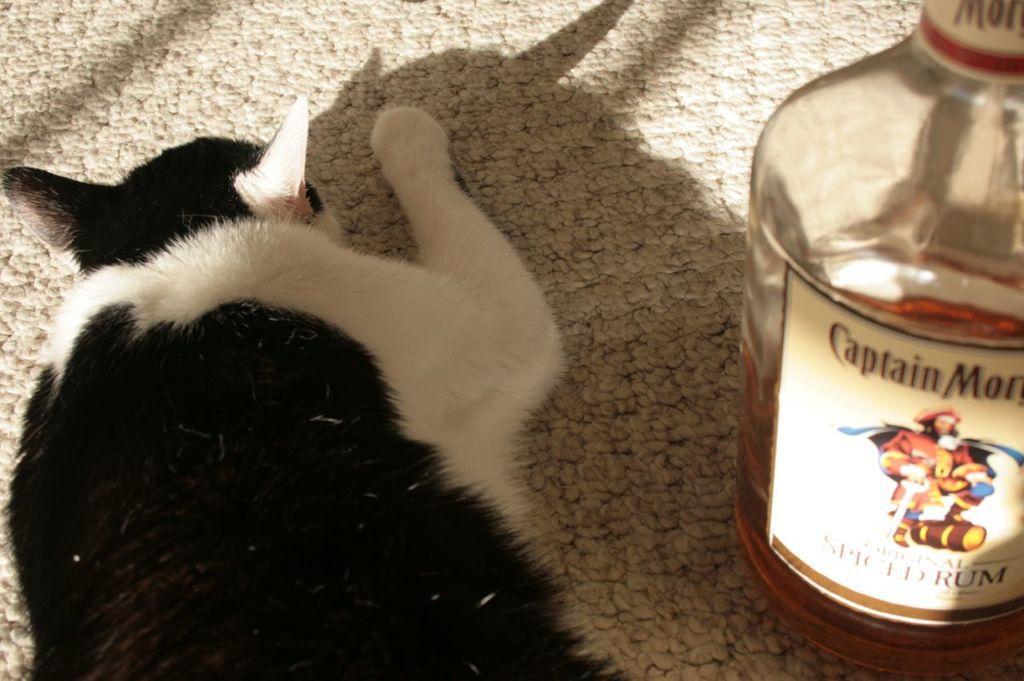Describe this image in one or two sentences. In this image there is a cat laying on the mat and at the right side there is a bottle. 